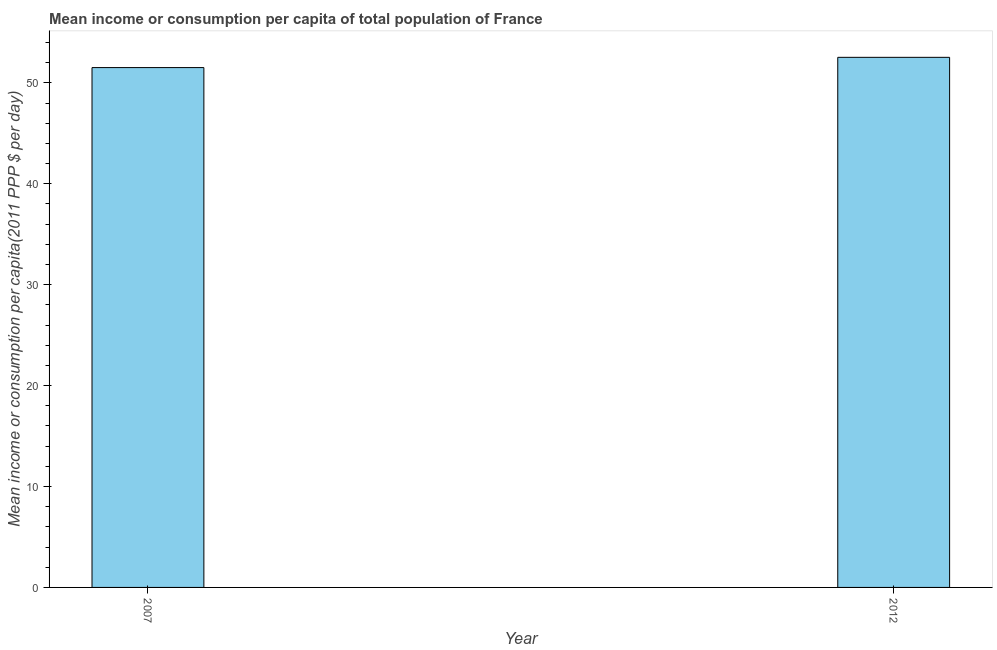What is the title of the graph?
Offer a terse response. Mean income or consumption per capita of total population of France. What is the label or title of the X-axis?
Ensure brevity in your answer.  Year. What is the label or title of the Y-axis?
Ensure brevity in your answer.  Mean income or consumption per capita(2011 PPP $ per day). What is the mean income or consumption in 2007?
Your answer should be compact. 51.51. Across all years, what is the maximum mean income or consumption?
Offer a very short reply. 52.53. Across all years, what is the minimum mean income or consumption?
Your response must be concise. 51.51. What is the sum of the mean income or consumption?
Your answer should be very brief. 104.04. What is the difference between the mean income or consumption in 2007 and 2012?
Keep it short and to the point. -1.02. What is the average mean income or consumption per year?
Your answer should be very brief. 52.02. What is the median mean income or consumption?
Your answer should be very brief. 52.02. Is the mean income or consumption in 2007 less than that in 2012?
Give a very brief answer. Yes. What is the difference between two consecutive major ticks on the Y-axis?
Offer a very short reply. 10. What is the Mean income or consumption per capita(2011 PPP $ per day) of 2007?
Ensure brevity in your answer.  51.51. What is the Mean income or consumption per capita(2011 PPP $ per day) of 2012?
Your answer should be compact. 52.53. What is the difference between the Mean income or consumption per capita(2011 PPP $ per day) in 2007 and 2012?
Your answer should be very brief. -1.02. What is the ratio of the Mean income or consumption per capita(2011 PPP $ per day) in 2007 to that in 2012?
Provide a short and direct response. 0.98. 